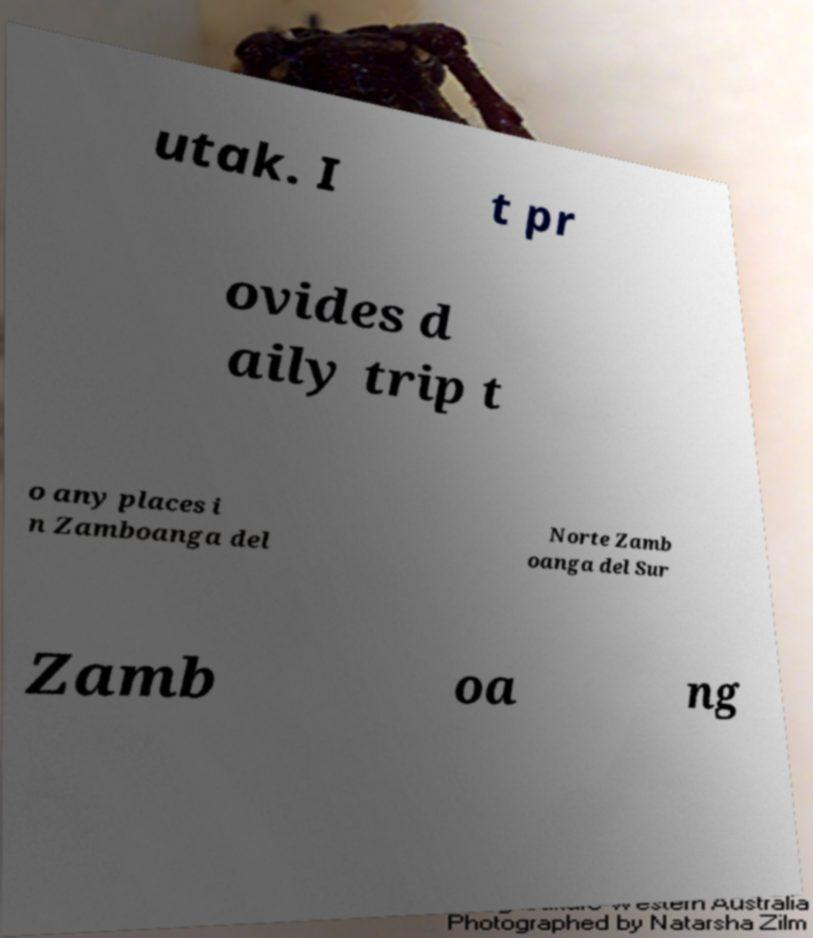Please read and relay the text visible in this image. What does it say? utak. I t pr ovides d aily trip t o any places i n Zamboanga del Norte Zamb oanga del Sur Zamb oa ng 